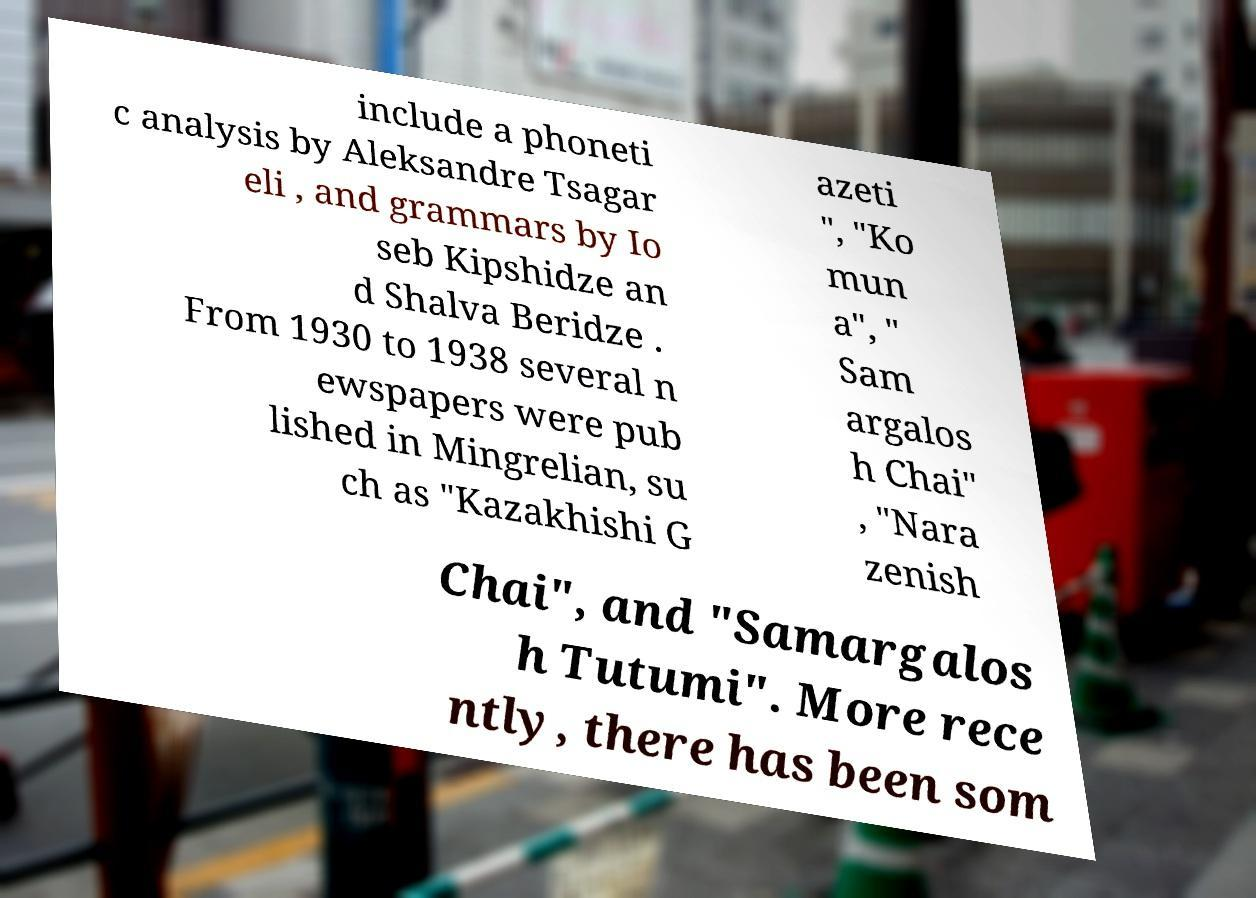For documentation purposes, I need the text within this image transcribed. Could you provide that? include a phoneti c analysis by Aleksandre Tsagar eli , and grammars by Io seb Kipshidze an d Shalva Beridze . From 1930 to 1938 several n ewspapers were pub lished in Mingrelian, su ch as "Kazakhishi G azeti ", "Ko mun a", " Sam argalos h Chai" , "Nara zenish Chai", and "Samargalos h Tutumi". More rece ntly, there has been som 